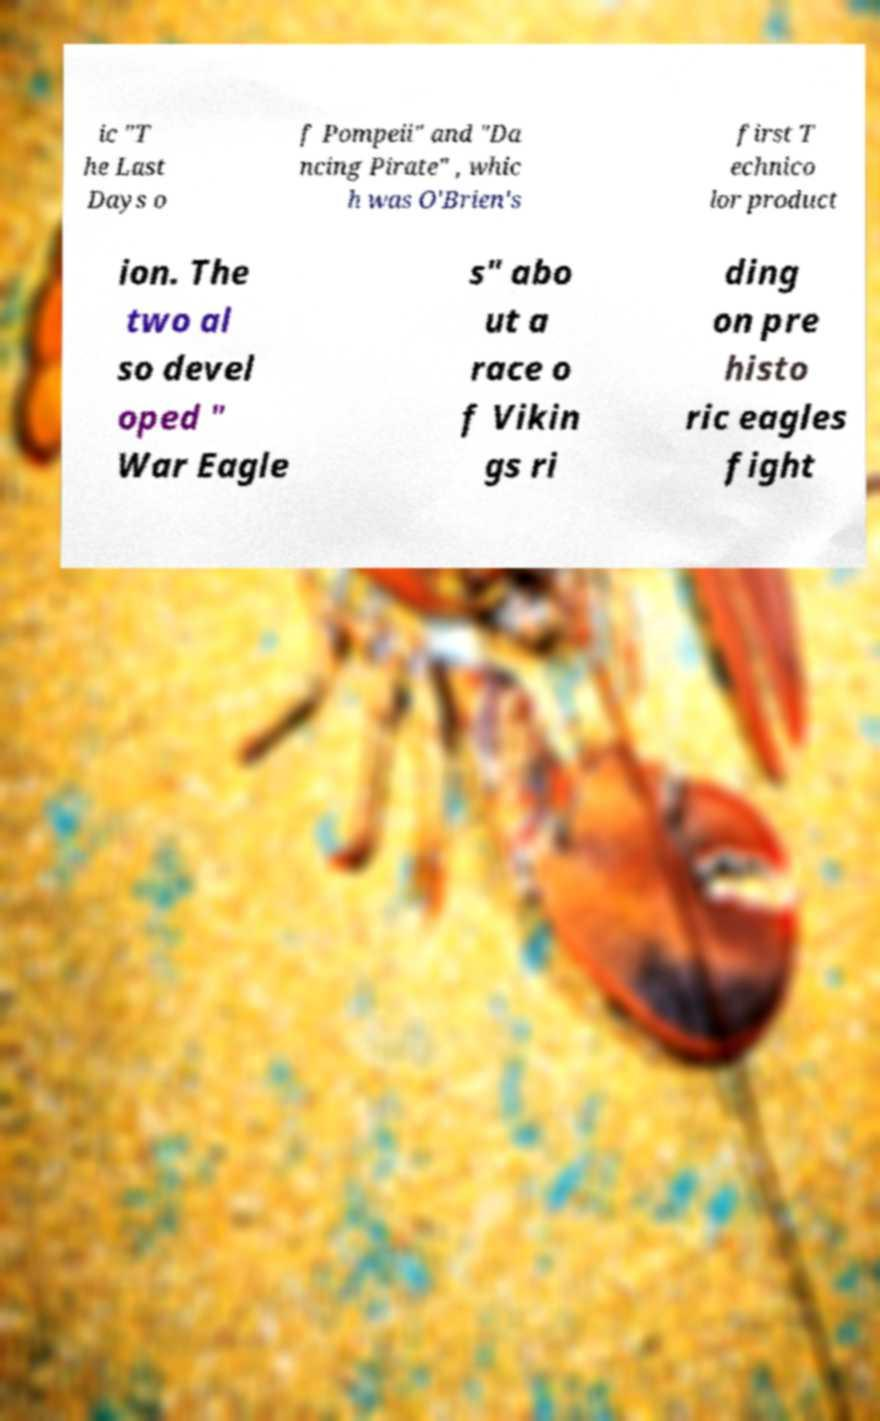Please identify and transcribe the text found in this image. ic "T he Last Days o f Pompeii" and "Da ncing Pirate" , whic h was O'Brien's first T echnico lor product ion. The two al so devel oped " War Eagle s" abo ut a race o f Vikin gs ri ding on pre histo ric eagles fight 